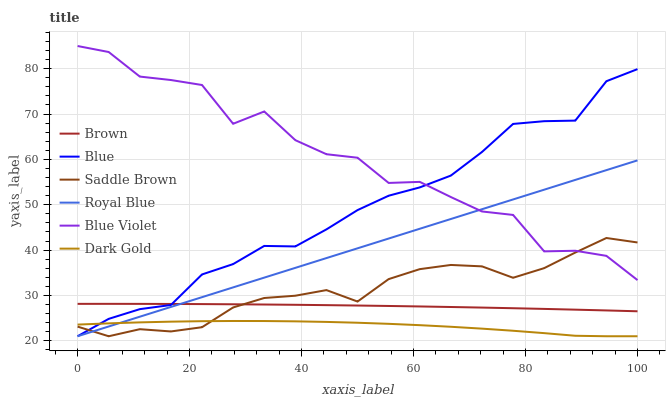Does Dark Gold have the minimum area under the curve?
Answer yes or no. Yes. Does Blue Violet have the maximum area under the curve?
Answer yes or no. Yes. Does Brown have the minimum area under the curve?
Answer yes or no. No. Does Brown have the maximum area under the curve?
Answer yes or no. No. Is Royal Blue the smoothest?
Answer yes or no. Yes. Is Blue Violet the roughest?
Answer yes or no. Yes. Is Brown the smoothest?
Answer yes or no. No. Is Brown the roughest?
Answer yes or no. No. Does Blue have the lowest value?
Answer yes or no. Yes. Does Brown have the lowest value?
Answer yes or no. No. Does Blue Violet have the highest value?
Answer yes or no. Yes. Does Brown have the highest value?
Answer yes or no. No. Is Dark Gold less than Blue Violet?
Answer yes or no. Yes. Is Blue Violet greater than Dark Gold?
Answer yes or no. Yes. Does Blue intersect Royal Blue?
Answer yes or no. Yes. Is Blue less than Royal Blue?
Answer yes or no. No. Is Blue greater than Royal Blue?
Answer yes or no. No. Does Dark Gold intersect Blue Violet?
Answer yes or no. No. 